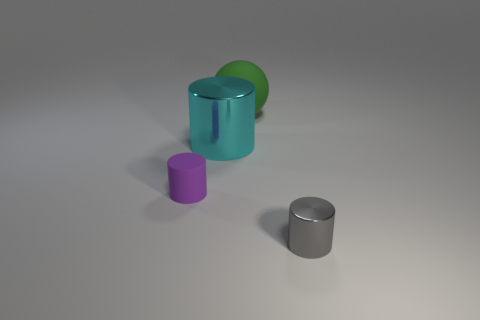There is a matte ball; is it the same color as the tiny cylinder that is behind the tiny metallic cylinder?
Your response must be concise. No. What is the size of the metallic cylinder that is on the right side of the large cyan object left of the metallic object that is on the right side of the big cyan cylinder?
Provide a succinct answer. Small. What number of big matte spheres have the same color as the tiny metal cylinder?
Your answer should be compact. 0. How many objects are either big cyan shiny objects or cylinders behind the small purple cylinder?
Offer a very short reply. 1. The large shiny cylinder is what color?
Your response must be concise. Cyan. What is the color of the large thing that is left of the big green thing?
Provide a short and direct response. Cyan. How many large green spheres are on the left side of the small thing behind the gray thing?
Your answer should be compact. 0. Do the green sphere and the metal object that is to the right of the large green object have the same size?
Your response must be concise. No. Is there a red matte ball of the same size as the gray shiny thing?
Offer a terse response. No. How many objects are tiny cylinders or large balls?
Make the answer very short. 3. 